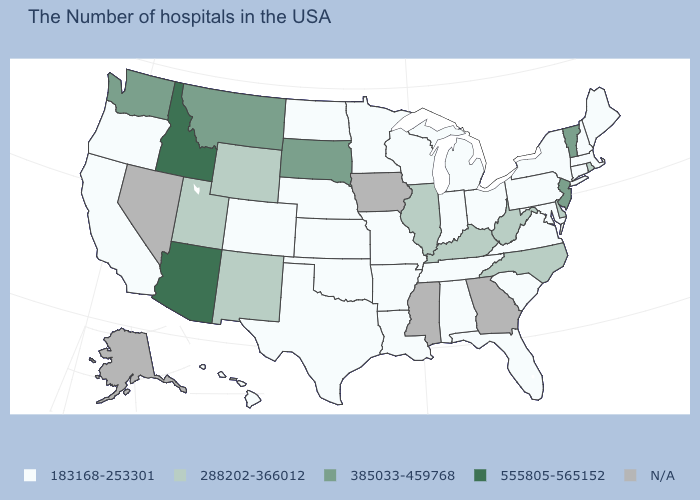Does the first symbol in the legend represent the smallest category?
Concise answer only. Yes. Which states hav the highest value in the West?
Answer briefly. Arizona, Idaho. What is the lowest value in the USA?
Be succinct. 183168-253301. What is the value of Vermont?
Quick response, please. 385033-459768. Which states have the lowest value in the MidWest?
Concise answer only. Ohio, Michigan, Indiana, Wisconsin, Missouri, Minnesota, Kansas, Nebraska, North Dakota. What is the lowest value in the West?
Answer briefly. 183168-253301. Does the map have missing data?
Short answer required. Yes. What is the lowest value in states that border Nevada?
Concise answer only. 183168-253301. What is the highest value in the USA?
Keep it brief. 555805-565152. Name the states that have a value in the range 555805-565152?
Give a very brief answer. Arizona, Idaho. Name the states that have a value in the range 555805-565152?
Write a very short answer. Arizona, Idaho. Name the states that have a value in the range 555805-565152?
Short answer required. Arizona, Idaho. Does the map have missing data?
Give a very brief answer. Yes. Name the states that have a value in the range 385033-459768?
Write a very short answer. Vermont, New Jersey, South Dakota, Montana, Washington. Does Missouri have the lowest value in the USA?
Write a very short answer. Yes. 